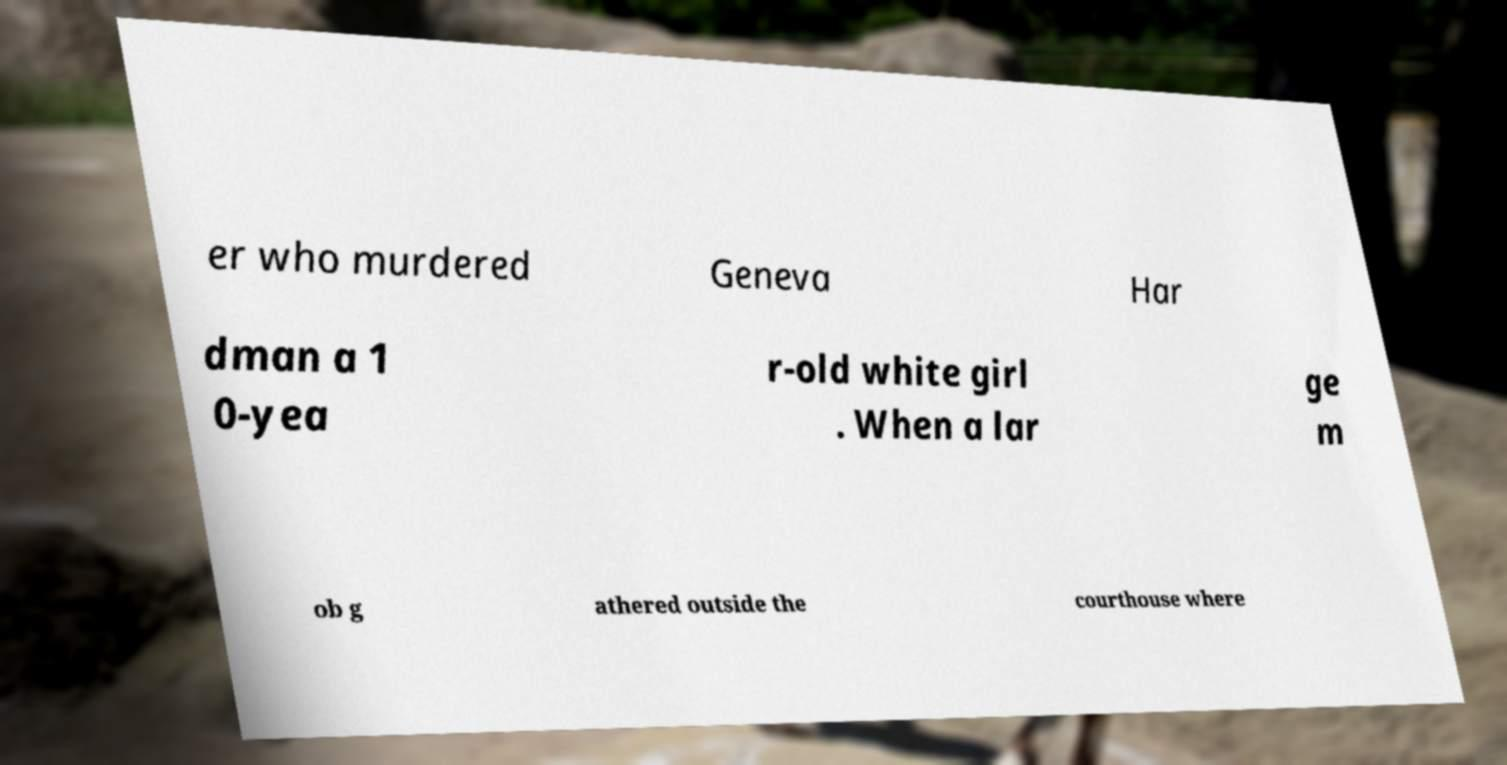Please identify and transcribe the text found in this image. er who murdered Geneva Har dman a 1 0-yea r-old white girl . When a lar ge m ob g athered outside the courthouse where 